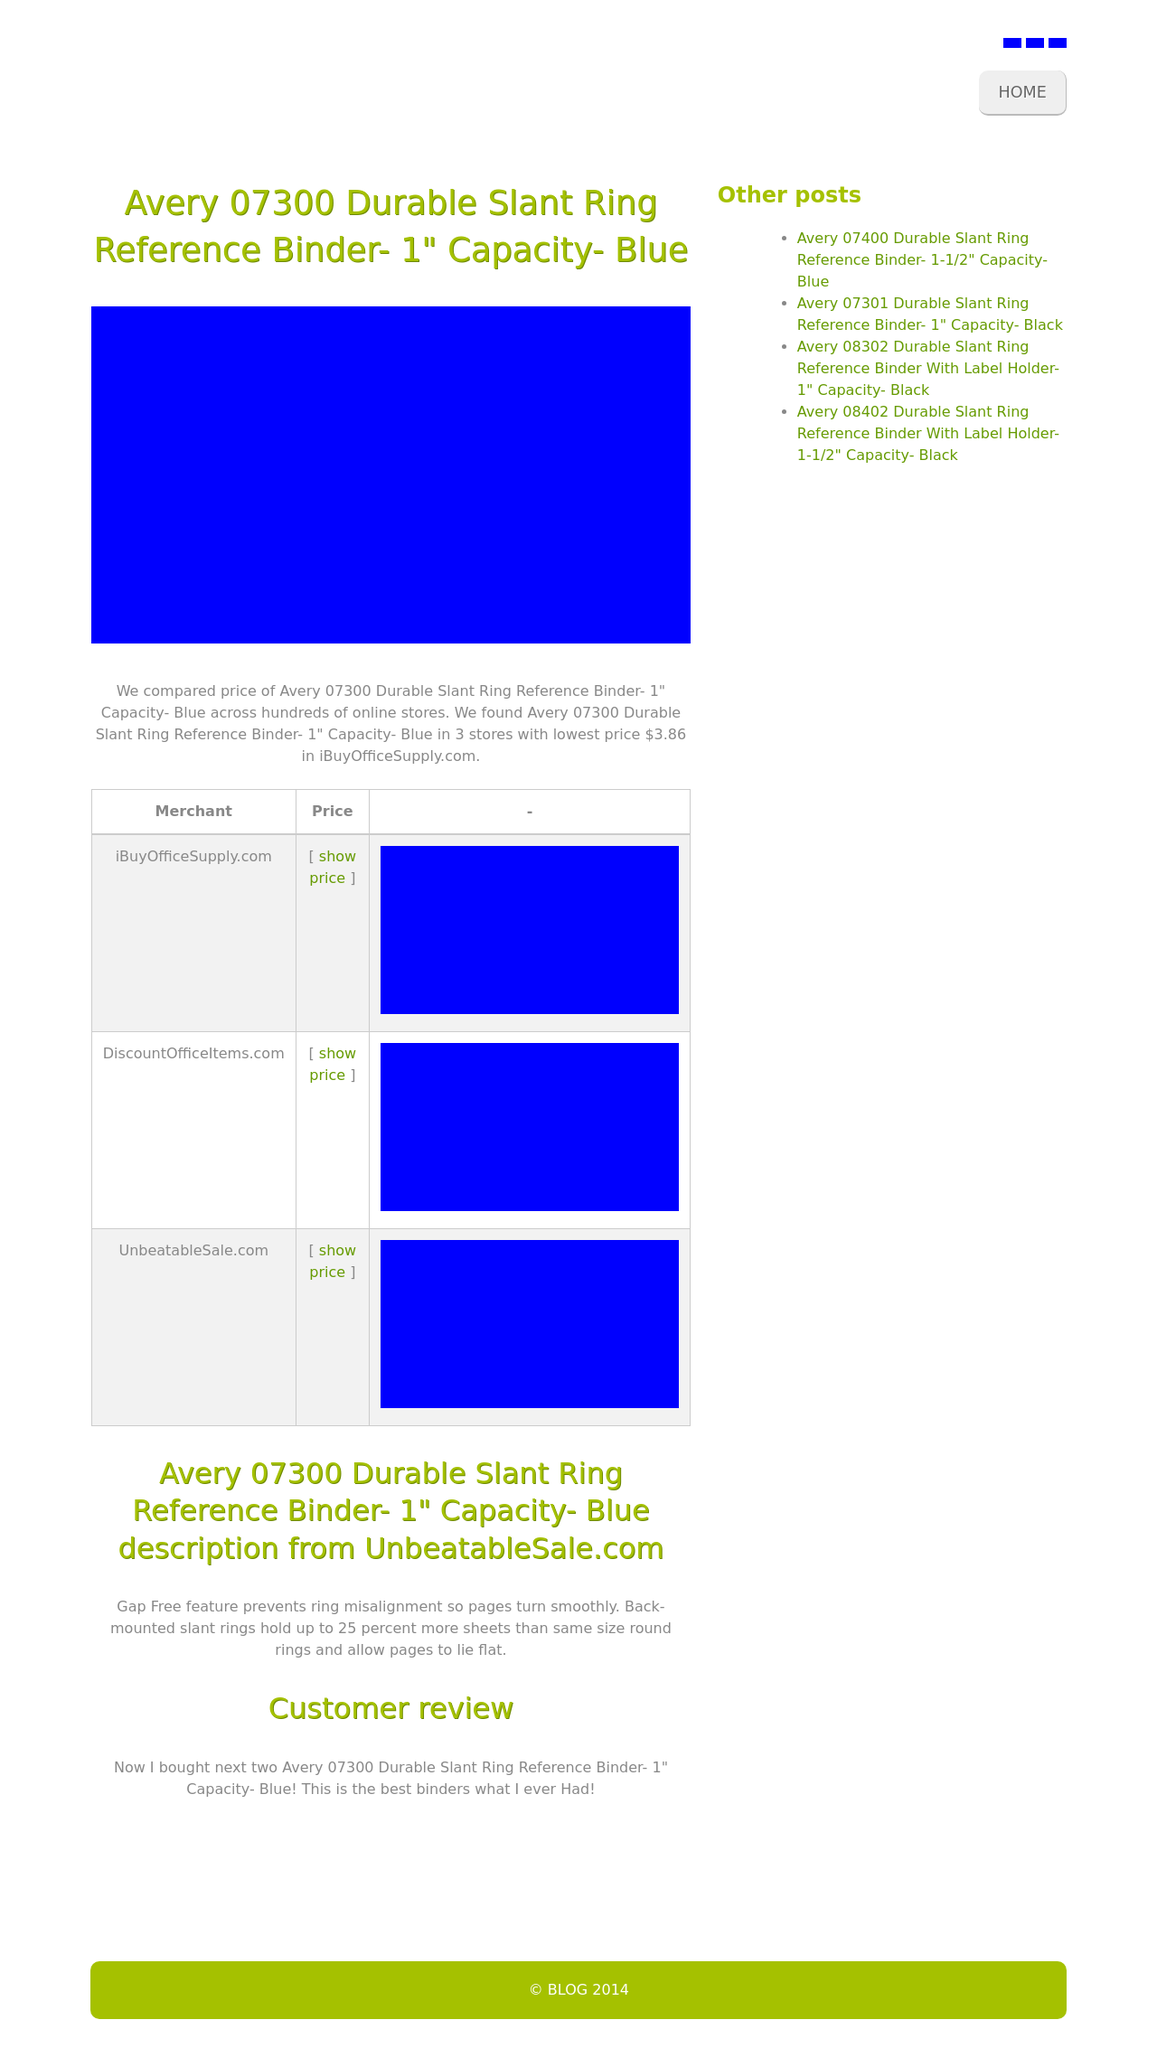Could you guide me through the process of developing this website with HTML? To develop a website similar to the one shown in the image, you would start with the basic structure using HTML before applying styles with CSS. Here is a simple example of how you could structure the HTML:

<!DOCTYPE html>
<html>
<head>
    <title>Your Website Title</title>
    <link rel='stylesheet' type='text/css' href='styles.css'>
</head>
<body>
    <header>
        <h1>Avery 07300 Durable Slant Ring Reference Binder- 1" Capacity- Blue</h1>
        <nav>
            <ul>
                <li><a href='#'>Home</a></li>
                <li><a href='#'>Other Products</a></li>
            </ul>
        </nav>
    </header>
    <main>
        <section>
            <p>We compared price of Avery 07300 Durable Slant Ring Reference Binder...</p>
        </section>
        <aside>
            <h3>Other posts</h3>
            <ul>
                <li><a href='#'>Avery 07400 Durable...</a></li>
            </ul>
        </aside>
    </main>
    <footer>
        <p>© BLOG 2014</p>
    </footer>
</body>
</html>

This basic structure outlines how to replicate a web page layout similar to the one in the image. You can then style it using CSS to match the visual presentation of the example screen. 